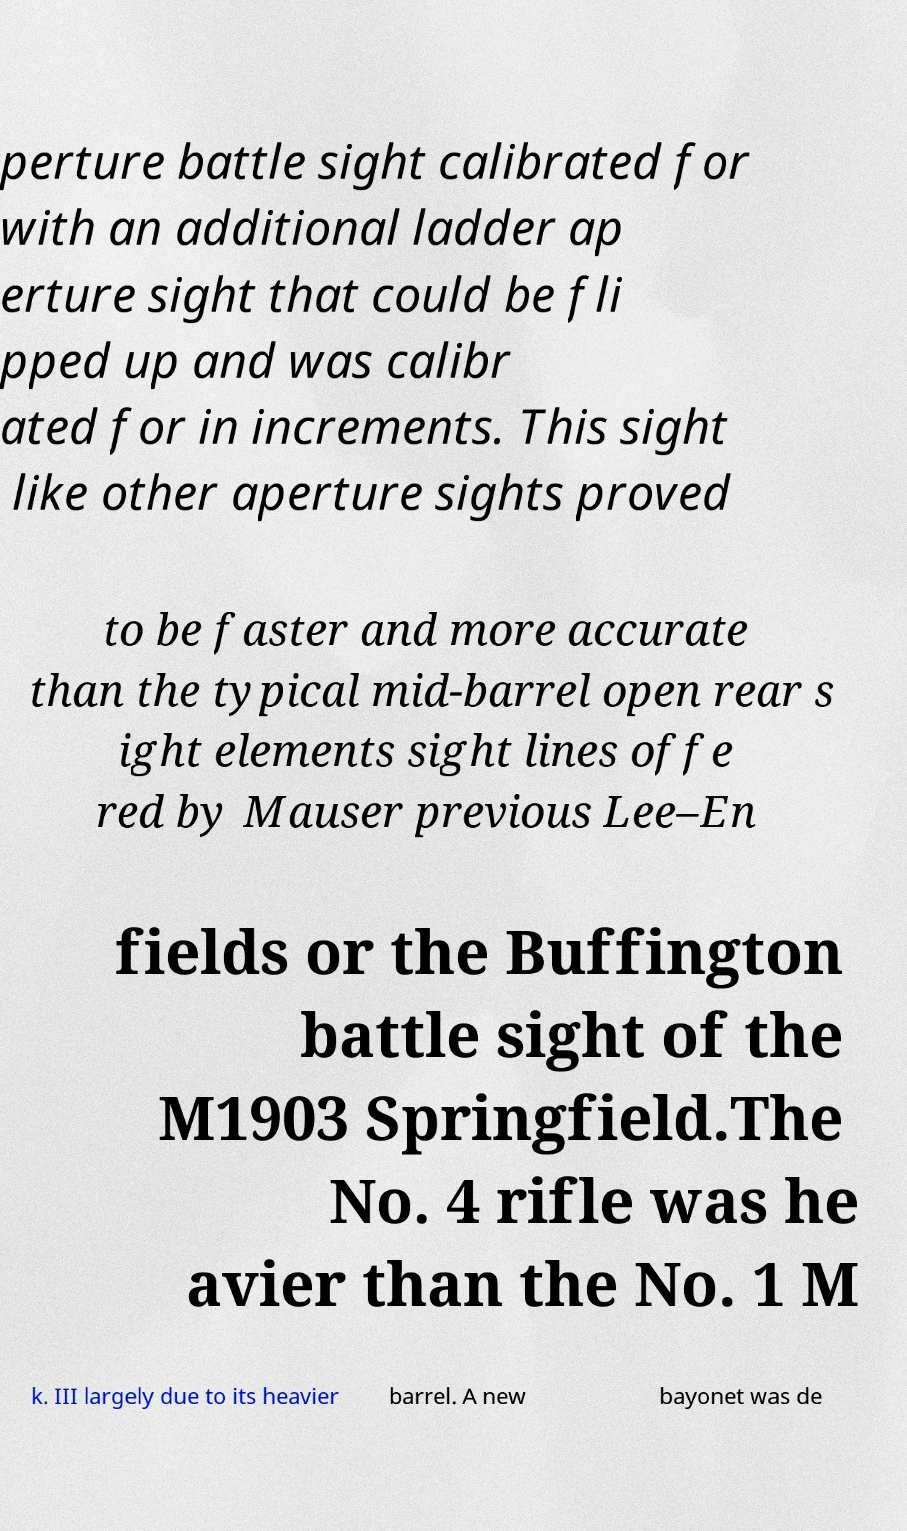I need the written content from this picture converted into text. Can you do that? perture battle sight calibrated for with an additional ladder ap erture sight that could be fli pped up and was calibr ated for in increments. This sight like other aperture sights proved to be faster and more accurate than the typical mid-barrel open rear s ight elements sight lines offe red by Mauser previous Lee–En fields or the Buffington battle sight of the M1903 Springfield.The No. 4 rifle was he avier than the No. 1 M k. III largely due to its heavier barrel. A new bayonet was de 